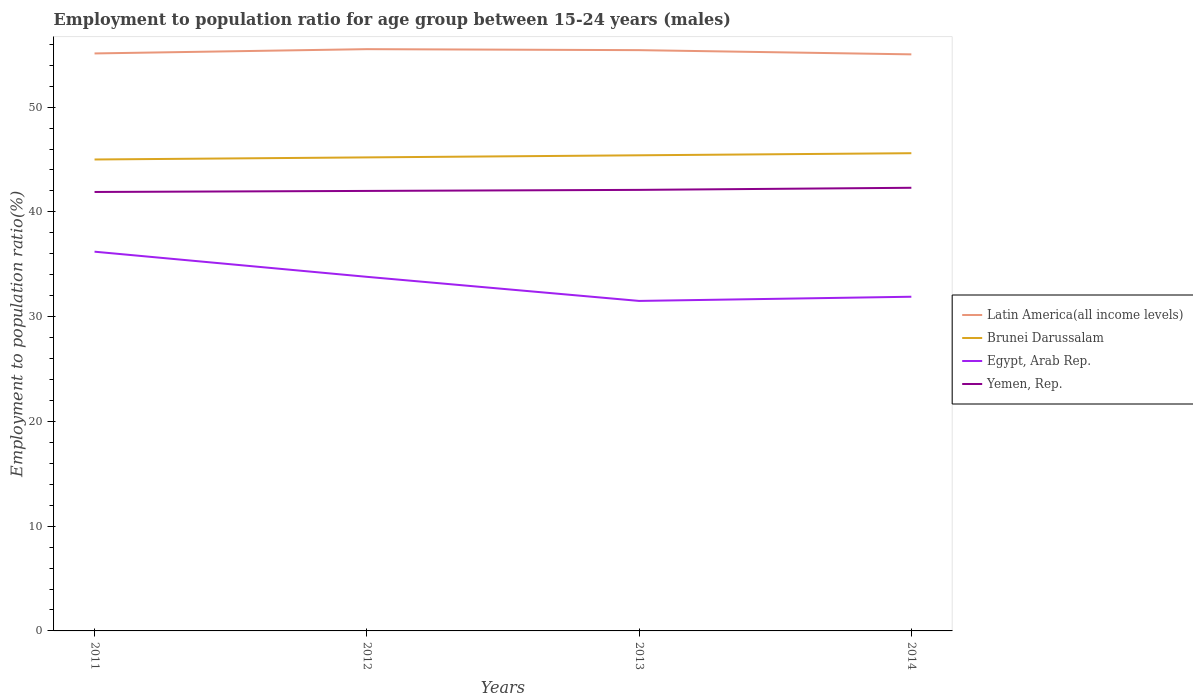How many different coloured lines are there?
Offer a very short reply. 4. Across all years, what is the maximum employment to population ratio in Egypt, Arab Rep.?
Ensure brevity in your answer.  31.5. In which year was the employment to population ratio in Latin America(all income levels) maximum?
Provide a succinct answer. 2014. What is the total employment to population ratio in Egypt, Arab Rep. in the graph?
Offer a very short reply. 2.4. What is the difference between the highest and the second highest employment to population ratio in Yemen, Rep.?
Your answer should be compact. 0.4. What is the difference between the highest and the lowest employment to population ratio in Yemen, Rep.?
Your response must be concise. 2. What is the difference between two consecutive major ticks on the Y-axis?
Give a very brief answer. 10. Are the values on the major ticks of Y-axis written in scientific E-notation?
Your answer should be very brief. No. Does the graph contain any zero values?
Your answer should be very brief. No. Where does the legend appear in the graph?
Provide a succinct answer. Center right. How many legend labels are there?
Provide a short and direct response. 4. What is the title of the graph?
Ensure brevity in your answer.  Employment to population ratio for age group between 15-24 years (males). What is the Employment to population ratio(%) of Latin America(all income levels) in 2011?
Your response must be concise. 55.12. What is the Employment to population ratio(%) in Brunei Darussalam in 2011?
Offer a terse response. 45. What is the Employment to population ratio(%) in Egypt, Arab Rep. in 2011?
Provide a succinct answer. 36.2. What is the Employment to population ratio(%) of Yemen, Rep. in 2011?
Give a very brief answer. 41.9. What is the Employment to population ratio(%) of Latin America(all income levels) in 2012?
Keep it short and to the point. 55.53. What is the Employment to population ratio(%) in Brunei Darussalam in 2012?
Keep it short and to the point. 45.2. What is the Employment to population ratio(%) of Egypt, Arab Rep. in 2012?
Provide a succinct answer. 33.8. What is the Employment to population ratio(%) of Yemen, Rep. in 2012?
Give a very brief answer. 42. What is the Employment to population ratio(%) of Latin America(all income levels) in 2013?
Keep it short and to the point. 55.44. What is the Employment to population ratio(%) of Brunei Darussalam in 2013?
Give a very brief answer. 45.4. What is the Employment to population ratio(%) of Egypt, Arab Rep. in 2013?
Provide a short and direct response. 31.5. What is the Employment to population ratio(%) of Yemen, Rep. in 2013?
Offer a very short reply. 42.1. What is the Employment to population ratio(%) in Latin America(all income levels) in 2014?
Your answer should be compact. 55.04. What is the Employment to population ratio(%) of Brunei Darussalam in 2014?
Provide a short and direct response. 45.6. What is the Employment to population ratio(%) of Egypt, Arab Rep. in 2014?
Your answer should be very brief. 31.9. What is the Employment to population ratio(%) of Yemen, Rep. in 2014?
Your response must be concise. 42.3. Across all years, what is the maximum Employment to population ratio(%) in Latin America(all income levels)?
Give a very brief answer. 55.53. Across all years, what is the maximum Employment to population ratio(%) in Brunei Darussalam?
Give a very brief answer. 45.6. Across all years, what is the maximum Employment to population ratio(%) in Egypt, Arab Rep.?
Offer a very short reply. 36.2. Across all years, what is the maximum Employment to population ratio(%) in Yemen, Rep.?
Offer a very short reply. 42.3. Across all years, what is the minimum Employment to population ratio(%) in Latin America(all income levels)?
Your response must be concise. 55.04. Across all years, what is the minimum Employment to population ratio(%) of Egypt, Arab Rep.?
Ensure brevity in your answer.  31.5. Across all years, what is the minimum Employment to population ratio(%) in Yemen, Rep.?
Ensure brevity in your answer.  41.9. What is the total Employment to population ratio(%) of Latin America(all income levels) in the graph?
Provide a succinct answer. 221.13. What is the total Employment to population ratio(%) of Brunei Darussalam in the graph?
Offer a very short reply. 181.2. What is the total Employment to population ratio(%) in Egypt, Arab Rep. in the graph?
Keep it short and to the point. 133.4. What is the total Employment to population ratio(%) in Yemen, Rep. in the graph?
Give a very brief answer. 168.3. What is the difference between the Employment to population ratio(%) in Latin America(all income levels) in 2011 and that in 2012?
Your response must be concise. -0.41. What is the difference between the Employment to population ratio(%) of Latin America(all income levels) in 2011 and that in 2013?
Ensure brevity in your answer.  -0.31. What is the difference between the Employment to population ratio(%) in Yemen, Rep. in 2011 and that in 2013?
Ensure brevity in your answer.  -0.2. What is the difference between the Employment to population ratio(%) in Latin America(all income levels) in 2011 and that in 2014?
Your answer should be very brief. 0.09. What is the difference between the Employment to population ratio(%) in Latin America(all income levels) in 2012 and that in 2013?
Offer a terse response. 0.09. What is the difference between the Employment to population ratio(%) in Brunei Darussalam in 2012 and that in 2013?
Offer a terse response. -0.2. What is the difference between the Employment to population ratio(%) of Latin America(all income levels) in 2012 and that in 2014?
Offer a very short reply. 0.5. What is the difference between the Employment to population ratio(%) of Yemen, Rep. in 2012 and that in 2014?
Your answer should be very brief. -0.3. What is the difference between the Employment to population ratio(%) of Latin America(all income levels) in 2013 and that in 2014?
Give a very brief answer. 0.4. What is the difference between the Employment to population ratio(%) in Brunei Darussalam in 2013 and that in 2014?
Ensure brevity in your answer.  -0.2. What is the difference between the Employment to population ratio(%) of Egypt, Arab Rep. in 2013 and that in 2014?
Offer a terse response. -0.4. What is the difference between the Employment to population ratio(%) of Latin America(all income levels) in 2011 and the Employment to population ratio(%) of Brunei Darussalam in 2012?
Offer a very short reply. 9.92. What is the difference between the Employment to population ratio(%) in Latin America(all income levels) in 2011 and the Employment to population ratio(%) in Egypt, Arab Rep. in 2012?
Provide a short and direct response. 21.32. What is the difference between the Employment to population ratio(%) of Latin America(all income levels) in 2011 and the Employment to population ratio(%) of Yemen, Rep. in 2012?
Your answer should be compact. 13.12. What is the difference between the Employment to population ratio(%) in Brunei Darussalam in 2011 and the Employment to population ratio(%) in Egypt, Arab Rep. in 2012?
Provide a succinct answer. 11.2. What is the difference between the Employment to population ratio(%) in Brunei Darussalam in 2011 and the Employment to population ratio(%) in Yemen, Rep. in 2012?
Provide a short and direct response. 3. What is the difference between the Employment to population ratio(%) of Latin America(all income levels) in 2011 and the Employment to population ratio(%) of Brunei Darussalam in 2013?
Your answer should be very brief. 9.72. What is the difference between the Employment to population ratio(%) in Latin America(all income levels) in 2011 and the Employment to population ratio(%) in Egypt, Arab Rep. in 2013?
Your answer should be very brief. 23.62. What is the difference between the Employment to population ratio(%) of Latin America(all income levels) in 2011 and the Employment to population ratio(%) of Yemen, Rep. in 2013?
Ensure brevity in your answer.  13.02. What is the difference between the Employment to population ratio(%) of Brunei Darussalam in 2011 and the Employment to population ratio(%) of Egypt, Arab Rep. in 2013?
Make the answer very short. 13.5. What is the difference between the Employment to population ratio(%) of Brunei Darussalam in 2011 and the Employment to population ratio(%) of Yemen, Rep. in 2013?
Provide a short and direct response. 2.9. What is the difference between the Employment to population ratio(%) of Latin America(all income levels) in 2011 and the Employment to population ratio(%) of Brunei Darussalam in 2014?
Provide a short and direct response. 9.52. What is the difference between the Employment to population ratio(%) of Latin America(all income levels) in 2011 and the Employment to population ratio(%) of Egypt, Arab Rep. in 2014?
Keep it short and to the point. 23.22. What is the difference between the Employment to population ratio(%) in Latin America(all income levels) in 2011 and the Employment to population ratio(%) in Yemen, Rep. in 2014?
Provide a succinct answer. 12.82. What is the difference between the Employment to population ratio(%) of Brunei Darussalam in 2011 and the Employment to population ratio(%) of Yemen, Rep. in 2014?
Your response must be concise. 2.7. What is the difference between the Employment to population ratio(%) in Latin America(all income levels) in 2012 and the Employment to population ratio(%) in Brunei Darussalam in 2013?
Your response must be concise. 10.13. What is the difference between the Employment to population ratio(%) of Latin America(all income levels) in 2012 and the Employment to population ratio(%) of Egypt, Arab Rep. in 2013?
Provide a succinct answer. 24.03. What is the difference between the Employment to population ratio(%) in Latin America(all income levels) in 2012 and the Employment to population ratio(%) in Yemen, Rep. in 2013?
Make the answer very short. 13.43. What is the difference between the Employment to population ratio(%) of Egypt, Arab Rep. in 2012 and the Employment to population ratio(%) of Yemen, Rep. in 2013?
Offer a very short reply. -8.3. What is the difference between the Employment to population ratio(%) of Latin America(all income levels) in 2012 and the Employment to population ratio(%) of Brunei Darussalam in 2014?
Your response must be concise. 9.93. What is the difference between the Employment to population ratio(%) in Latin America(all income levels) in 2012 and the Employment to population ratio(%) in Egypt, Arab Rep. in 2014?
Give a very brief answer. 23.63. What is the difference between the Employment to population ratio(%) in Latin America(all income levels) in 2012 and the Employment to population ratio(%) in Yemen, Rep. in 2014?
Your response must be concise. 13.23. What is the difference between the Employment to population ratio(%) of Brunei Darussalam in 2012 and the Employment to population ratio(%) of Yemen, Rep. in 2014?
Provide a short and direct response. 2.9. What is the difference between the Employment to population ratio(%) of Egypt, Arab Rep. in 2012 and the Employment to population ratio(%) of Yemen, Rep. in 2014?
Offer a terse response. -8.5. What is the difference between the Employment to population ratio(%) in Latin America(all income levels) in 2013 and the Employment to population ratio(%) in Brunei Darussalam in 2014?
Your answer should be compact. 9.84. What is the difference between the Employment to population ratio(%) of Latin America(all income levels) in 2013 and the Employment to population ratio(%) of Egypt, Arab Rep. in 2014?
Keep it short and to the point. 23.54. What is the difference between the Employment to population ratio(%) in Latin America(all income levels) in 2013 and the Employment to population ratio(%) in Yemen, Rep. in 2014?
Your answer should be very brief. 13.14. What is the difference between the Employment to population ratio(%) of Brunei Darussalam in 2013 and the Employment to population ratio(%) of Yemen, Rep. in 2014?
Keep it short and to the point. 3.1. What is the average Employment to population ratio(%) of Latin America(all income levels) per year?
Give a very brief answer. 55.28. What is the average Employment to population ratio(%) in Brunei Darussalam per year?
Provide a succinct answer. 45.3. What is the average Employment to population ratio(%) of Egypt, Arab Rep. per year?
Your answer should be very brief. 33.35. What is the average Employment to population ratio(%) in Yemen, Rep. per year?
Your answer should be very brief. 42.08. In the year 2011, what is the difference between the Employment to population ratio(%) in Latin America(all income levels) and Employment to population ratio(%) in Brunei Darussalam?
Your answer should be very brief. 10.12. In the year 2011, what is the difference between the Employment to population ratio(%) of Latin America(all income levels) and Employment to population ratio(%) of Egypt, Arab Rep.?
Ensure brevity in your answer.  18.92. In the year 2011, what is the difference between the Employment to population ratio(%) in Latin America(all income levels) and Employment to population ratio(%) in Yemen, Rep.?
Ensure brevity in your answer.  13.22. In the year 2011, what is the difference between the Employment to population ratio(%) of Egypt, Arab Rep. and Employment to population ratio(%) of Yemen, Rep.?
Make the answer very short. -5.7. In the year 2012, what is the difference between the Employment to population ratio(%) in Latin America(all income levels) and Employment to population ratio(%) in Brunei Darussalam?
Offer a very short reply. 10.33. In the year 2012, what is the difference between the Employment to population ratio(%) in Latin America(all income levels) and Employment to population ratio(%) in Egypt, Arab Rep.?
Provide a succinct answer. 21.73. In the year 2012, what is the difference between the Employment to population ratio(%) in Latin America(all income levels) and Employment to population ratio(%) in Yemen, Rep.?
Make the answer very short. 13.53. In the year 2012, what is the difference between the Employment to population ratio(%) of Brunei Darussalam and Employment to population ratio(%) of Egypt, Arab Rep.?
Your answer should be very brief. 11.4. In the year 2012, what is the difference between the Employment to population ratio(%) of Egypt, Arab Rep. and Employment to population ratio(%) of Yemen, Rep.?
Your answer should be compact. -8.2. In the year 2013, what is the difference between the Employment to population ratio(%) in Latin America(all income levels) and Employment to population ratio(%) in Brunei Darussalam?
Give a very brief answer. 10.04. In the year 2013, what is the difference between the Employment to population ratio(%) of Latin America(all income levels) and Employment to population ratio(%) of Egypt, Arab Rep.?
Ensure brevity in your answer.  23.94. In the year 2013, what is the difference between the Employment to population ratio(%) of Latin America(all income levels) and Employment to population ratio(%) of Yemen, Rep.?
Offer a very short reply. 13.34. In the year 2013, what is the difference between the Employment to population ratio(%) of Brunei Darussalam and Employment to population ratio(%) of Egypt, Arab Rep.?
Offer a very short reply. 13.9. In the year 2013, what is the difference between the Employment to population ratio(%) of Brunei Darussalam and Employment to population ratio(%) of Yemen, Rep.?
Offer a very short reply. 3.3. In the year 2013, what is the difference between the Employment to population ratio(%) of Egypt, Arab Rep. and Employment to population ratio(%) of Yemen, Rep.?
Offer a terse response. -10.6. In the year 2014, what is the difference between the Employment to population ratio(%) in Latin America(all income levels) and Employment to population ratio(%) in Brunei Darussalam?
Your answer should be very brief. 9.44. In the year 2014, what is the difference between the Employment to population ratio(%) in Latin America(all income levels) and Employment to population ratio(%) in Egypt, Arab Rep.?
Your answer should be very brief. 23.14. In the year 2014, what is the difference between the Employment to population ratio(%) in Latin America(all income levels) and Employment to population ratio(%) in Yemen, Rep.?
Keep it short and to the point. 12.74. In the year 2014, what is the difference between the Employment to population ratio(%) in Brunei Darussalam and Employment to population ratio(%) in Egypt, Arab Rep.?
Provide a short and direct response. 13.7. What is the ratio of the Employment to population ratio(%) of Brunei Darussalam in 2011 to that in 2012?
Your answer should be very brief. 1. What is the ratio of the Employment to population ratio(%) of Egypt, Arab Rep. in 2011 to that in 2012?
Your response must be concise. 1.07. What is the ratio of the Employment to population ratio(%) in Egypt, Arab Rep. in 2011 to that in 2013?
Your answer should be very brief. 1.15. What is the ratio of the Employment to population ratio(%) in Latin America(all income levels) in 2011 to that in 2014?
Give a very brief answer. 1. What is the ratio of the Employment to population ratio(%) in Brunei Darussalam in 2011 to that in 2014?
Your answer should be compact. 0.99. What is the ratio of the Employment to population ratio(%) in Egypt, Arab Rep. in 2011 to that in 2014?
Offer a very short reply. 1.13. What is the ratio of the Employment to population ratio(%) of Yemen, Rep. in 2011 to that in 2014?
Provide a short and direct response. 0.99. What is the ratio of the Employment to population ratio(%) in Egypt, Arab Rep. in 2012 to that in 2013?
Keep it short and to the point. 1.07. What is the ratio of the Employment to population ratio(%) of Brunei Darussalam in 2012 to that in 2014?
Keep it short and to the point. 0.99. What is the ratio of the Employment to population ratio(%) in Egypt, Arab Rep. in 2012 to that in 2014?
Provide a succinct answer. 1.06. What is the ratio of the Employment to population ratio(%) of Latin America(all income levels) in 2013 to that in 2014?
Keep it short and to the point. 1.01. What is the ratio of the Employment to population ratio(%) in Egypt, Arab Rep. in 2013 to that in 2014?
Your response must be concise. 0.99. What is the ratio of the Employment to population ratio(%) in Yemen, Rep. in 2013 to that in 2014?
Offer a very short reply. 1. What is the difference between the highest and the second highest Employment to population ratio(%) in Latin America(all income levels)?
Offer a very short reply. 0.09. What is the difference between the highest and the second highest Employment to population ratio(%) in Brunei Darussalam?
Your answer should be compact. 0.2. What is the difference between the highest and the second highest Employment to population ratio(%) in Egypt, Arab Rep.?
Your answer should be very brief. 2.4. What is the difference between the highest and the second highest Employment to population ratio(%) in Yemen, Rep.?
Offer a terse response. 0.2. What is the difference between the highest and the lowest Employment to population ratio(%) in Latin America(all income levels)?
Keep it short and to the point. 0.5. 